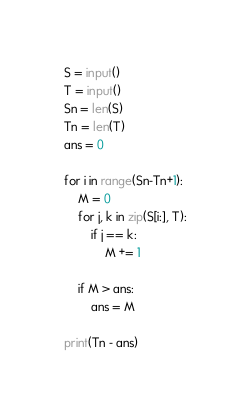Convert code to text. <code><loc_0><loc_0><loc_500><loc_500><_Python_>S = input()
T = input()
Sn = len(S)
Tn = len(T)
ans = 0

for i in range(Sn-Tn+1):
    M = 0
    for j, k in zip(S[i:], T):
        if j == k:
            M += 1
    
    if M > ans:
        ans = M

print(Tn - ans)</code> 